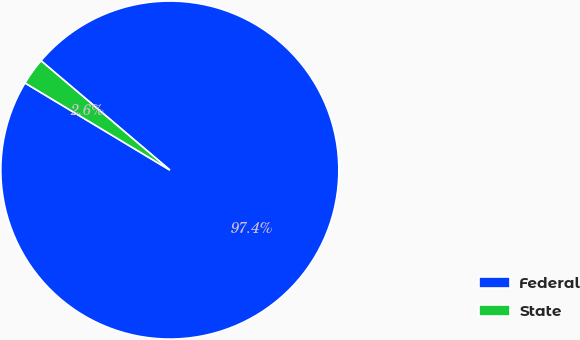Convert chart. <chart><loc_0><loc_0><loc_500><loc_500><pie_chart><fcel>Federal<fcel>State<nl><fcel>97.42%<fcel>2.58%<nl></chart> 